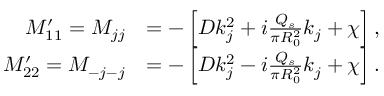Convert formula to latex. <formula><loc_0><loc_0><loc_500><loc_500>\begin{array} { r l } { M _ { 1 1 } ^ { \prime } = M _ { j j } } & { = - \left [ D k _ { j } ^ { 2 } + i \frac { Q _ { s } } { \pi R _ { 0 } ^ { 2 } } k _ { j } + \chi \right ] , } \\ { M _ { 2 2 } ^ { \prime } = M _ { - j - j } } & { = - \left [ D k _ { j } ^ { 2 } - i \frac { Q _ { s } } { \pi R _ { 0 } ^ { 2 } } k _ { j } + \chi \right ] . } \end{array}</formula> 